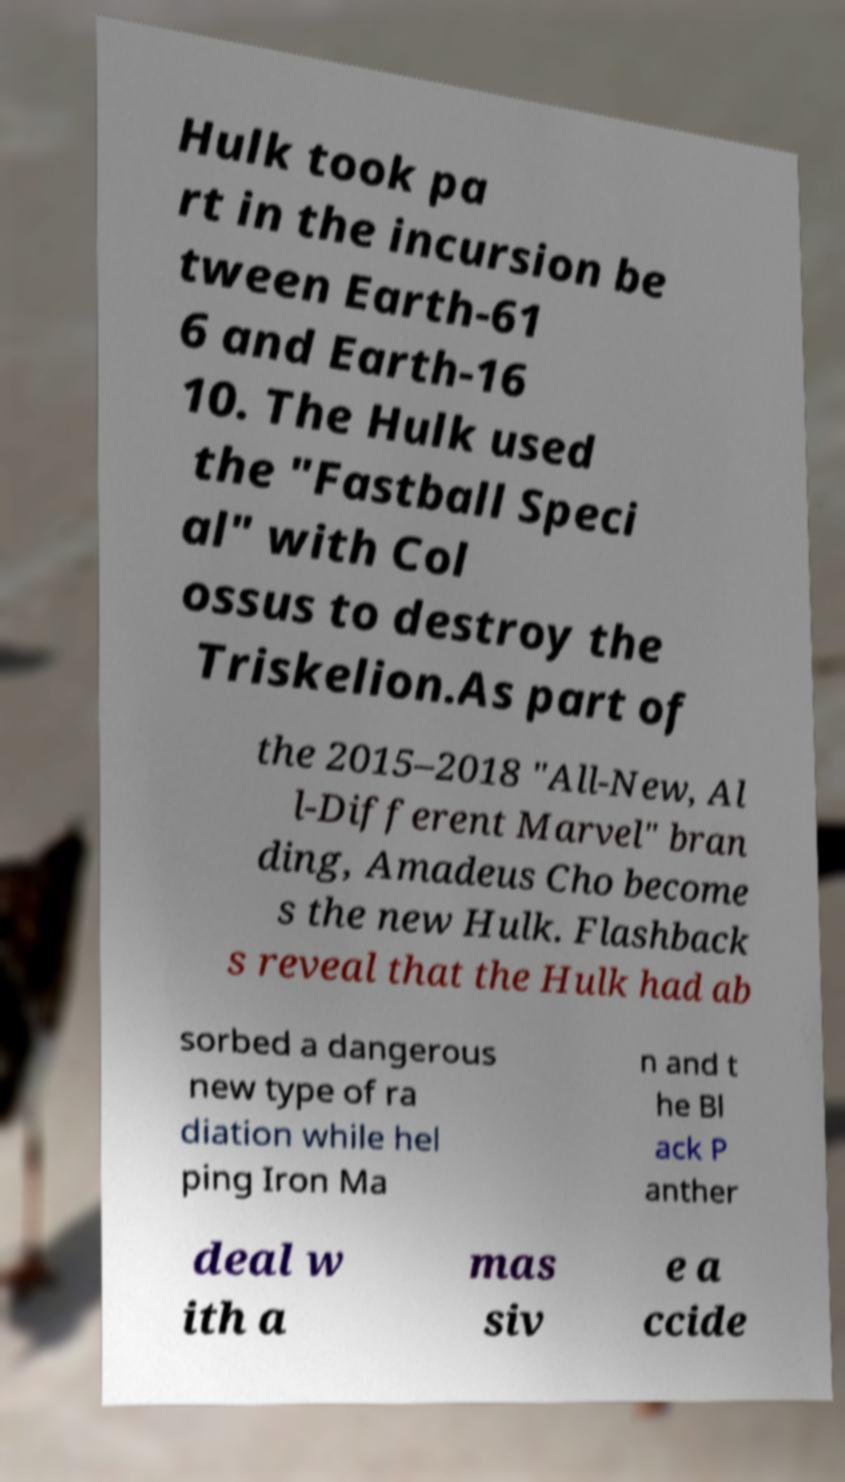Can you read and provide the text displayed in the image?This photo seems to have some interesting text. Can you extract and type it out for me? Hulk took pa rt in the incursion be tween Earth-61 6 and Earth-16 10. The Hulk used the "Fastball Speci al" with Col ossus to destroy the Triskelion.As part of the 2015–2018 "All-New, Al l-Different Marvel" bran ding, Amadeus Cho become s the new Hulk. Flashback s reveal that the Hulk had ab sorbed a dangerous new type of ra diation while hel ping Iron Ma n and t he Bl ack P anther deal w ith a mas siv e a ccide 